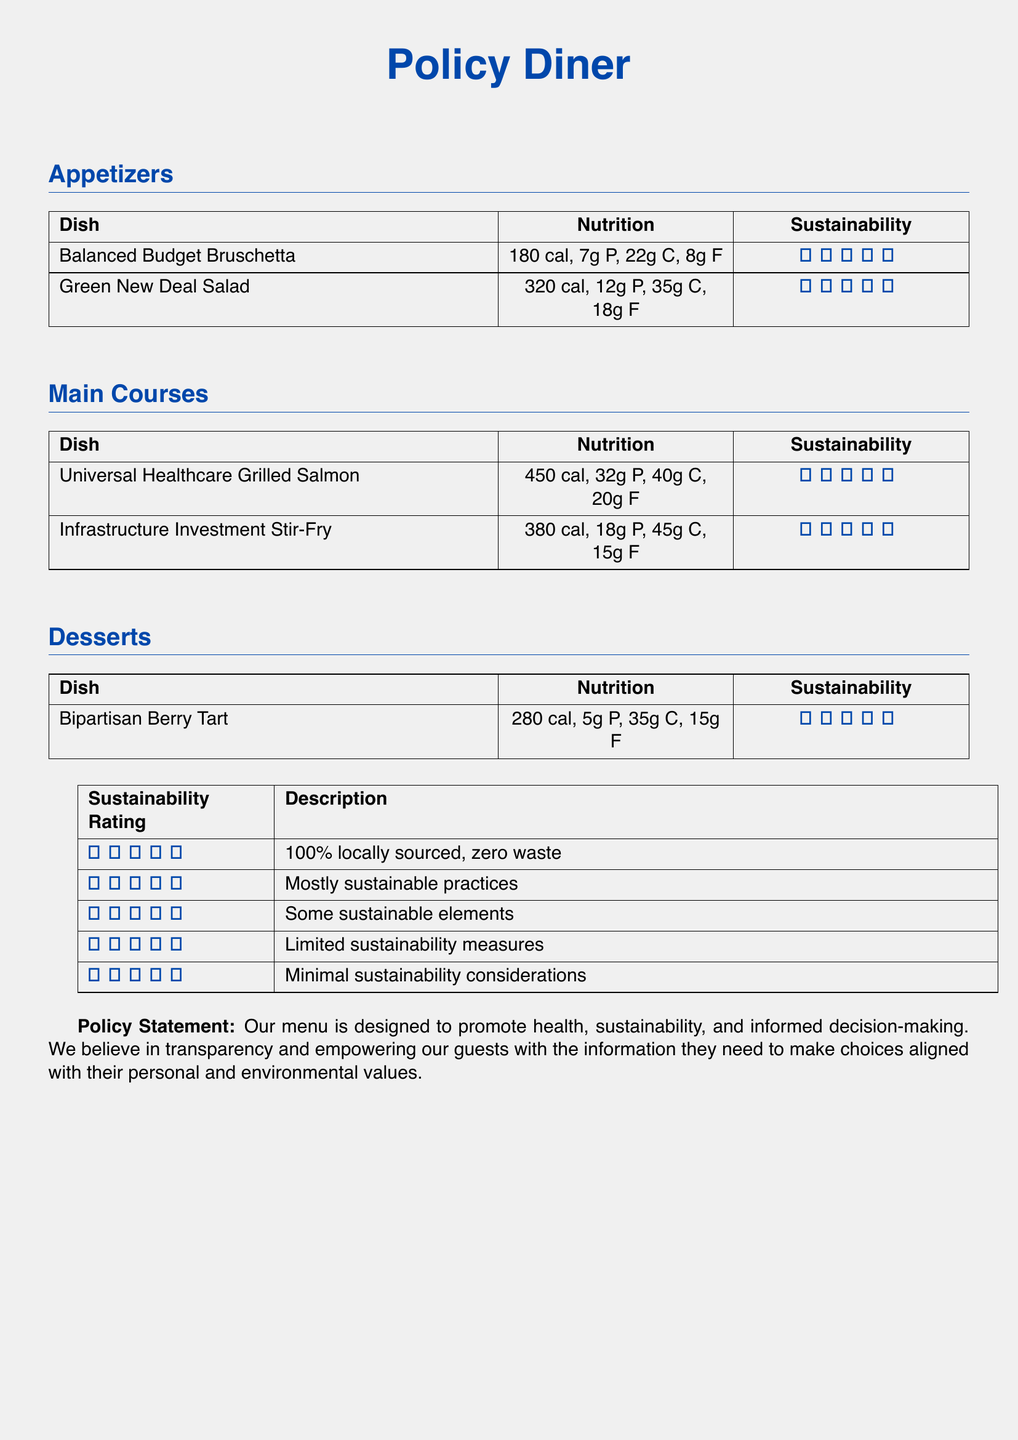What is the calorie count of the Green New Deal Salad? The calorie count of the Green New Deal Salad is specified in the nutrition section of the menu.
Answer: 320 cal How many grams of protein are in the Universal Healthcare Grilled Salmon? The grams of protein for the Universal Healthcare Grilled Salmon are detailed in the nutrition section.
Answer: 32g P What sustainability rating does the Bipartisan Berry Tart have? The sustainability rating for the Bipartisan Berry Tart is listed in the sustainability column on the dessert menu.
Answer: ★★★★☆ Which dish has the highest calorie count? The dish with the highest calorie count can be determined by comparing the values in the nutrition section of the main courses.
Answer: Universal Healthcare Grilled Salmon What does a sustainability rating of 3 indicate? The description for a sustainability rating of 3 is provided in the sustainability rating table.
Answer: Some sustainable elements How many calories are in the Balanced Budget Bruschetta? The number of calories for the Balanced Budget Bruschetta is found in the nutrition part of the appetizer section.
Answer: 180 cal What is the total number of dishes listed in the menu? The total number of dishes can be obtained by counting all the entries in the appetizers, main courses, and desserts sections.
Answer: 6 What type of cuisine does this menu focus on? The menu is designed with a policy-focused approach, prioritizing health and sustainability, rather than a specific cuisine.
Answer: Policy-focused 